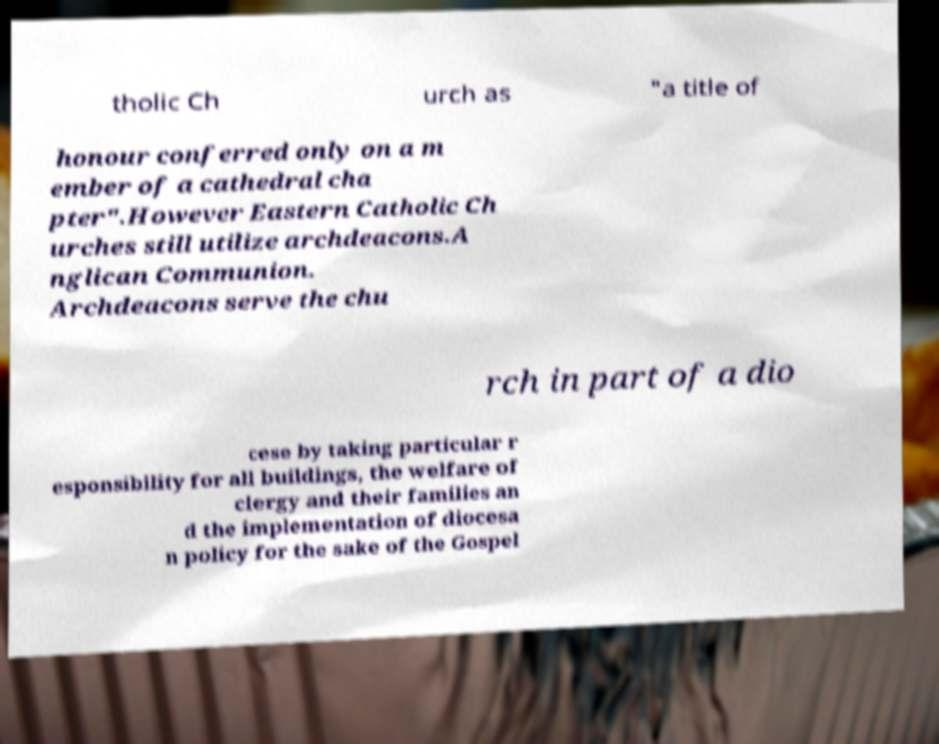Please identify and transcribe the text found in this image. tholic Ch urch as "a title of honour conferred only on a m ember of a cathedral cha pter".However Eastern Catholic Ch urches still utilize archdeacons.A nglican Communion. Archdeacons serve the chu rch in part of a dio cese by taking particular r esponsibility for all buildings, the welfare of clergy and their families an d the implementation of diocesa n policy for the sake of the Gospel 